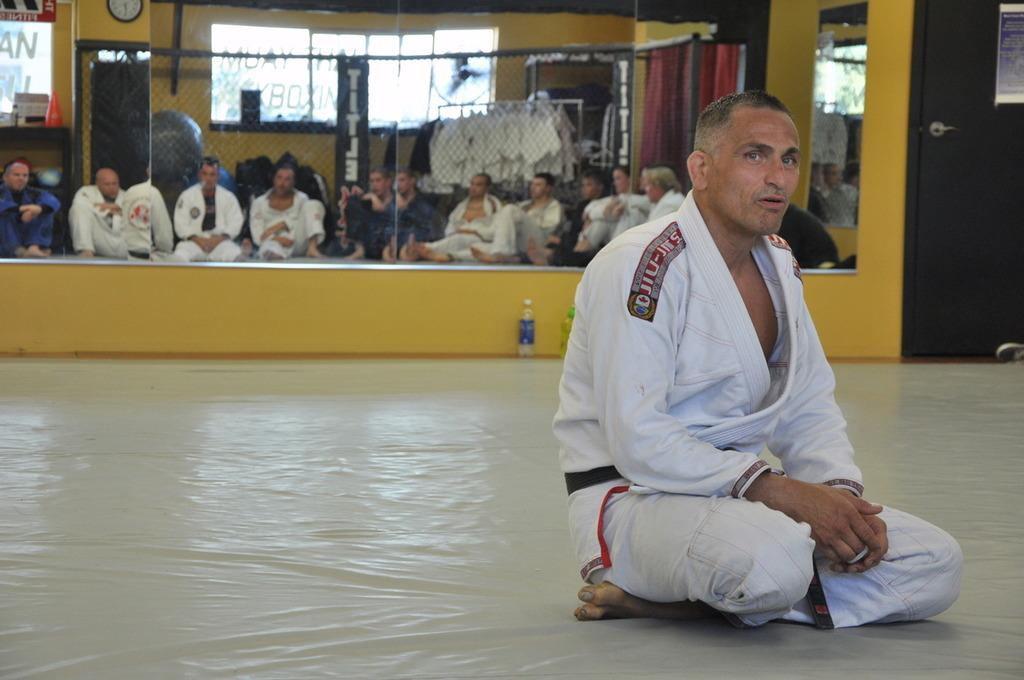<image>
Relay a brief, clear account of the picture shown. A man in a Jujitsu uniform sitting in front of a mirror. 